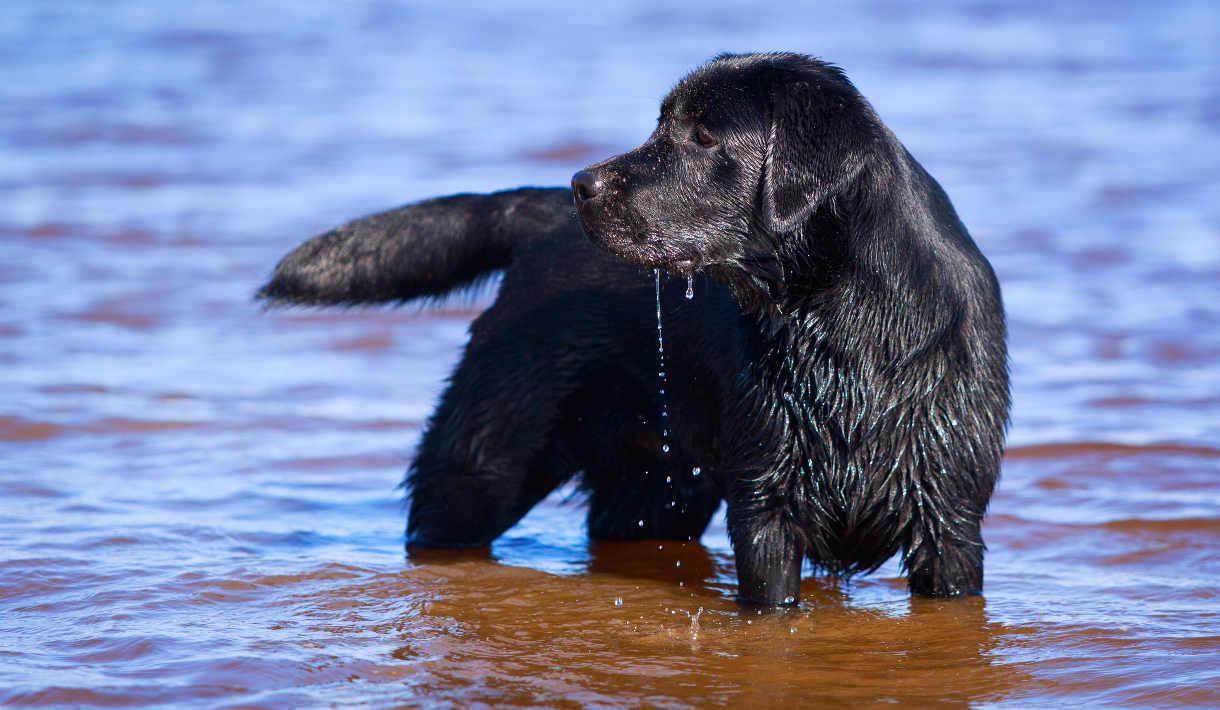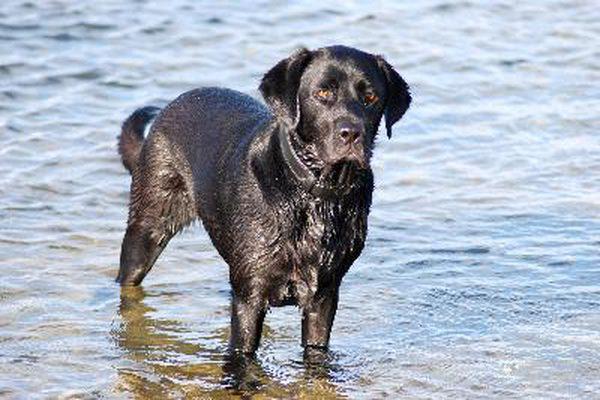The first image is the image on the left, the second image is the image on the right. For the images shown, is this caption "At least one dog has it's tail out of the water." true? Answer yes or no. Yes. The first image is the image on the left, the second image is the image on the right. Considering the images on both sides, is "In one image the dog is facing forward, and in the other it is facing to the side." valid? Answer yes or no. Yes. 